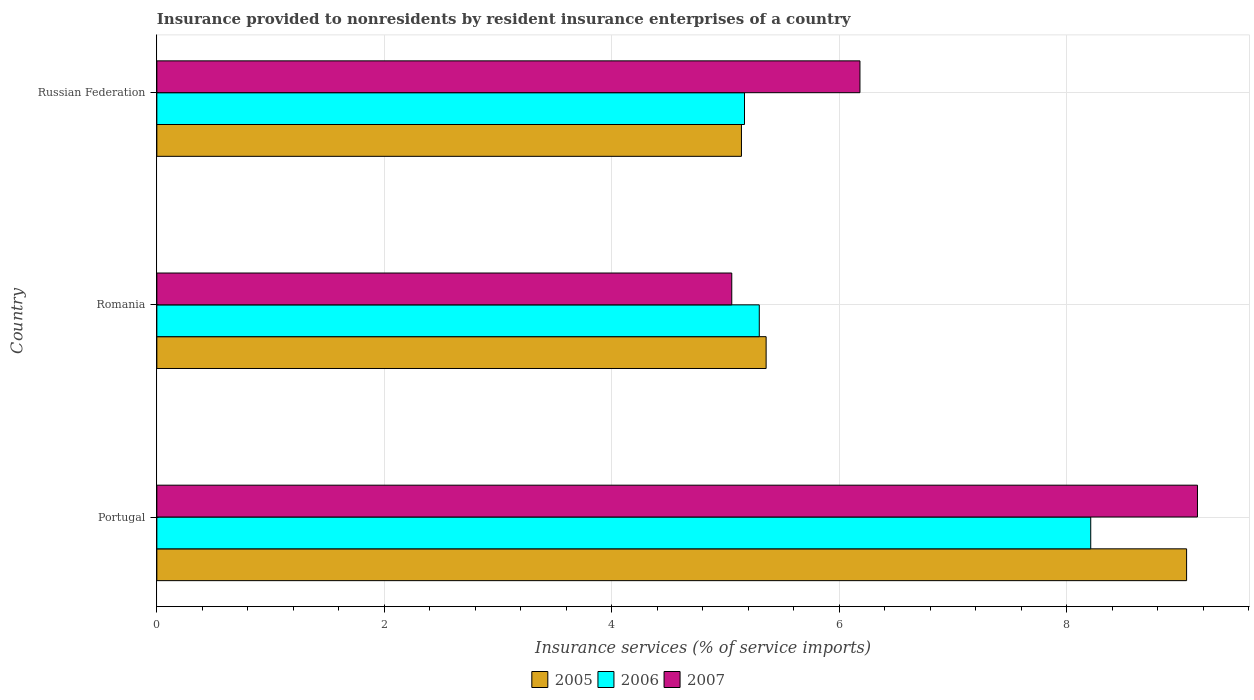How many different coloured bars are there?
Your response must be concise. 3. What is the label of the 1st group of bars from the top?
Provide a short and direct response. Russian Federation. What is the insurance provided to nonresidents in 2005 in Romania?
Offer a very short reply. 5.36. Across all countries, what is the maximum insurance provided to nonresidents in 2005?
Make the answer very short. 9.05. Across all countries, what is the minimum insurance provided to nonresidents in 2006?
Provide a short and direct response. 5.17. In which country was the insurance provided to nonresidents in 2007 maximum?
Your answer should be very brief. Portugal. In which country was the insurance provided to nonresidents in 2006 minimum?
Your answer should be very brief. Russian Federation. What is the total insurance provided to nonresidents in 2006 in the graph?
Offer a very short reply. 18.67. What is the difference between the insurance provided to nonresidents in 2006 in Portugal and that in Russian Federation?
Ensure brevity in your answer.  3.04. What is the difference between the insurance provided to nonresidents in 2005 in Romania and the insurance provided to nonresidents in 2007 in Russian Federation?
Give a very brief answer. -0.82. What is the average insurance provided to nonresidents in 2005 per country?
Give a very brief answer. 6.52. What is the difference between the insurance provided to nonresidents in 2006 and insurance provided to nonresidents in 2007 in Romania?
Your answer should be compact. 0.24. In how many countries, is the insurance provided to nonresidents in 2006 greater than 4 %?
Offer a terse response. 3. What is the ratio of the insurance provided to nonresidents in 2007 in Portugal to that in Russian Federation?
Provide a short and direct response. 1.48. Is the insurance provided to nonresidents in 2007 in Romania less than that in Russian Federation?
Ensure brevity in your answer.  Yes. Is the difference between the insurance provided to nonresidents in 2006 in Portugal and Romania greater than the difference between the insurance provided to nonresidents in 2007 in Portugal and Romania?
Provide a succinct answer. No. What is the difference between the highest and the second highest insurance provided to nonresidents in 2007?
Offer a terse response. 2.97. What is the difference between the highest and the lowest insurance provided to nonresidents in 2005?
Offer a very short reply. 3.91. Is the sum of the insurance provided to nonresidents in 2007 in Romania and Russian Federation greater than the maximum insurance provided to nonresidents in 2005 across all countries?
Ensure brevity in your answer.  Yes. What does the 2nd bar from the top in Romania represents?
Provide a succinct answer. 2006. What does the 2nd bar from the bottom in Romania represents?
Ensure brevity in your answer.  2006. Is it the case that in every country, the sum of the insurance provided to nonresidents in 2006 and insurance provided to nonresidents in 2007 is greater than the insurance provided to nonresidents in 2005?
Your response must be concise. Yes. Are all the bars in the graph horizontal?
Provide a succinct answer. Yes. What is the difference between two consecutive major ticks on the X-axis?
Offer a terse response. 2. Are the values on the major ticks of X-axis written in scientific E-notation?
Offer a very short reply. No. Does the graph contain any zero values?
Keep it short and to the point. No. Does the graph contain grids?
Provide a short and direct response. Yes. How many legend labels are there?
Offer a very short reply. 3. What is the title of the graph?
Offer a terse response. Insurance provided to nonresidents by resident insurance enterprises of a country. What is the label or title of the X-axis?
Offer a very short reply. Insurance services (% of service imports). What is the Insurance services (% of service imports) of 2005 in Portugal?
Your answer should be compact. 9.05. What is the Insurance services (% of service imports) in 2006 in Portugal?
Your response must be concise. 8.21. What is the Insurance services (% of service imports) in 2007 in Portugal?
Your response must be concise. 9.15. What is the Insurance services (% of service imports) of 2005 in Romania?
Your response must be concise. 5.36. What is the Insurance services (% of service imports) in 2006 in Romania?
Make the answer very short. 5.3. What is the Insurance services (% of service imports) in 2007 in Romania?
Keep it short and to the point. 5.05. What is the Insurance services (% of service imports) of 2005 in Russian Federation?
Your answer should be very brief. 5.14. What is the Insurance services (% of service imports) of 2006 in Russian Federation?
Your answer should be very brief. 5.17. What is the Insurance services (% of service imports) in 2007 in Russian Federation?
Make the answer very short. 6.18. Across all countries, what is the maximum Insurance services (% of service imports) in 2005?
Give a very brief answer. 9.05. Across all countries, what is the maximum Insurance services (% of service imports) in 2006?
Provide a short and direct response. 8.21. Across all countries, what is the maximum Insurance services (% of service imports) of 2007?
Your answer should be very brief. 9.15. Across all countries, what is the minimum Insurance services (% of service imports) of 2005?
Your response must be concise. 5.14. Across all countries, what is the minimum Insurance services (% of service imports) in 2006?
Keep it short and to the point. 5.17. Across all countries, what is the minimum Insurance services (% of service imports) of 2007?
Offer a very short reply. 5.05. What is the total Insurance services (% of service imports) of 2005 in the graph?
Provide a succinct answer. 19.55. What is the total Insurance services (% of service imports) in 2006 in the graph?
Offer a terse response. 18.68. What is the total Insurance services (% of service imports) in 2007 in the graph?
Your response must be concise. 20.39. What is the difference between the Insurance services (% of service imports) in 2005 in Portugal and that in Romania?
Your answer should be very brief. 3.7. What is the difference between the Insurance services (% of service imports) in 2006 in Portugal and that in Romania?
Make the answer very short. 2.91. What is the difference between the Insurance services (% of service imports) of 2007 in Portugal and that in Romania?
Provide a short and direct response. 4.09. What is the difference between the Insurance services (% of service imports) in 2005 in Portugal and that in Russian Federation?
Offer a very short reply. 3.91. What is the difference between the Insurance services (% of service imports) of 2006 in Portugal and that in Russian Federation?
Make the answer very short. 3.04. What is the difference between the Insurance services (% of service imports) in 2007 in Portugal and that in Russian Federation?
Keep it short and to the point. 2.97. What is the difference between the Insurance services (% of service imports) in 2005 in Romania and that in Russian Federation?
Your response must be concise. 0.22. What is the difference between the Insurance services (% of service imports) of 2006 in Romania and that in Russian Federation?
Offer a very short reply. 0.13. What is the difference between the Insurance services (% of service imports) in 2007 in Romania and that in Russian Federation?
Offer a very short reply. -1.13. What is the difference between the Insurance services (% of service imports) of 2005 in Portugal and the Insurance services (% of service imports) of 2006 in Romania?
Your answer should be compact. 3.76. What is the difference between the Insurance services (% of service imports) in 2005 in Portugal and the Insurance services (% of service imports) in 2007 in Romania?
Your answer should be very brief. 4. What is the difference between the Insurance services (% of service imports) in 2006 in Portugal and the Insurance services (% of service imports) in 2007 in Romania?
Your answer should be compact. 3.16. What is the difference between the Insurance services (% of service imports) in 2005 in Portugal and the Insurance services (% of service imports) in 2006 in Russian Federation?
Ensure brevity in your answer.  3.89. What is the difference between the Insurance services (% of service imports) of 2005 in Portugal and the Insurance services (% of service imports) of 2007 in Russian Federation?
Make the answer very short. 2.87. What is the difference between the Insurance services (% of service imports) in 2006 in Portugal and the Insurance services (% of service imports) in 2007 in Russian Federation?
Make the answer very short. 2.03. What is the difference between the Insurance services (% of service imports) of 2005 in Romania and the Insurance services (% of service imports) of 2006 in Russian Federation?
Keep it short and to the point. 0.19. What is the difference between the Insurance services (% of service imports) of 2005 in Romania and the Insurance services (% of service imports) of 2007 in Russian Federation?
Provide a short and direct response. -0.82. What is the difference between the Insurance services (% of service imports) of 2006 in Romania and the Insurance services (% of service imports) of 2007 in Russian Federation?
Make the answer very short. -0.89. What is the average Insurance services (% of service imports) in 2005 per country?
Provide a short and direct response. 6.52. What is the average Insurance services (% of service imports) in 2006 per country?
Offer a terse response. 6.22. What is the average Insurance services (% of service imports) in 2007 per country?
Provide a succinct answer. 6.8. What is the difference between the Insurance services (% of service imports) of 2005 and Insurance services (% of service imports) of 2006 in Portugal?
Your answer should be compact. 0.84. What is the difference between the Insurance services (% of service imports) of 2005 and Insurance services (% of service imports) of 2007 in Portugal?
Offer a very short reply. -0.1. What is the difference between the Insurance services (% of service imports) of 2006 and Insurance services (% of service imports) of 2007 in Portugal?
Your response must be concise. -0.94. What is the difference between the Insurance services (% of service imports) of 2005 and Insurance services (% of service imports) of 2006 in Romania?
Your response must be concise. 0.06. What is the difference between the Insurance services (% of service imports) in 2005 and Insurance services (% of service imports) in 2007 in Romania?
Provide a succinct answer. 0.3. What is the difference between the Insurance services (% of service imports) of 2006 and Insurance services (% of service imports) of 2007 in Romania?
Make the answer very short. 0.24. What is the difference between the Insurance services (% of service imports) of 2005 and Insurance services (% of service imports) of 2006 in Russian Federation?
Offer a terse response. -0.03. What is the difference between the Insurance services (% of service imports) in 2005 and Insurance services (% of service imports) in 2007 in Russian Federation?
Provide a short and direct response. -1.04. What is the difference between the Insurance services (% of service imports) in 2006 and Insurance services (% of service imports) in 2007 in Russian Federation?
Keep it short and to the point. -1.02. What is the ratio of the Insurance services (% of service imports) of 2005 in Portugal to that in Romania?
Provide a short and direct response. 1.69. What is the ratio of the Insurance services (% of service imports) in 2006 in Portugal to that in Romania?
Give a very brief answer. 1.55. What is the ratio of the Insurance services (% of service imports) of 2007 in Portugal to that in Romania?
Keep it short and to the point. 1.81. What is the ratio of the Insurance services (% of service imports) of 2005 in Portugal to that in Russian Federation?
Your response must be concise. 1.76. What is the ratio of the Insurance services (% of service imports) of 2006 in Portugal to that in Russian Federation?
Your answer should be compact. 1.59. What is the ratio of the Insurance services (% of service imports) of 2007 in Portugal to that in Russian Federation?
Your answer should be very brief. 1.48. What is the ratio of the Insurance services (% of service imports) in 2005 in Romania to that in Russian Federation?
Provide a succinct answer. 1.04. What is the ratio of the Insurance services (% of service imports) of 2006 in Romania to that in Russian Federation?
Offer a terse response. 1.03. What is the ratio of the Insurance services (% of service imports) of 2007 in Romania to that in Russian Federation?
Make the answer very short. 0.82. What is the difference between the highest and the second highest Insurance services (% of service imports) of 2005?
Keep it short and to the point. 3.7. What is the difference between the highest and the second highest Insurance services (% of service imports) of 2006?
Your answer should be compact. 2.91. What is the difference between the highest and the second highest Insurance services (% of service imports) of 2007?
Provide a short and direct response. 2.97. What is the difference between the highest and the lowest Insurance services (% of service imports) in 2005?
Ensure brevity in your answer.  3.91. What is the difference between the highest and the lowest Insurance services (% of service imports) in 2006?
Ensure brevity in your answer.  3.04. What is the difference between the highest and the lowest Insurance services (% of service imports) in 2007?
Provide a succinct answer. 4.09. 